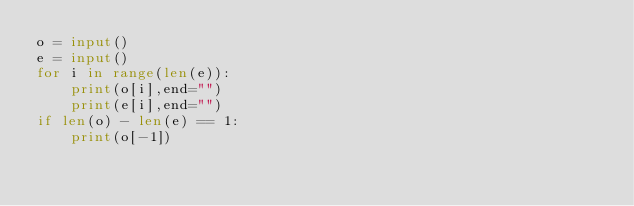<code> <loc_0><loc_0><loc_500><loc_500><_Python_>o = input()
e = input()
for i in range(len(e)):
    print(o[i],end="")
    print(e[i],end="")
if len(o) - len(e) == 1:
    print(o[-1])</code> 